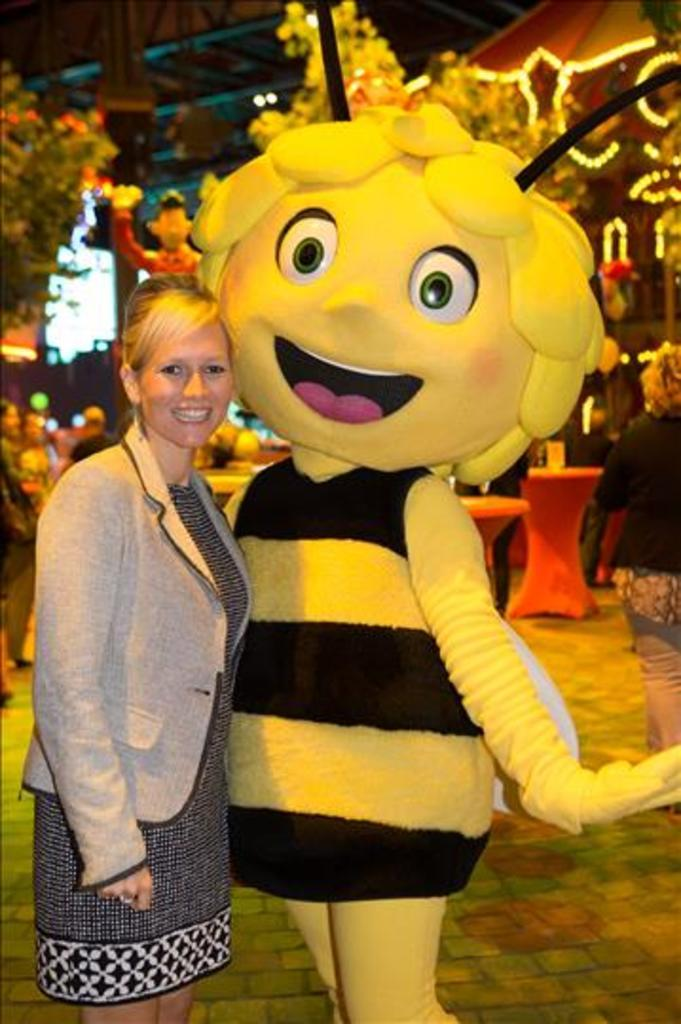What is the main subject of the image? There is a woman standing in the image. What is the woman doing in the image? The woman is standing at a mascot. Can you describe the background of the image? The background of the image is not clear, but there are trees, decorative lights, poles, and a few persons visible. What type of objects can be seen in the background? There are objects in the background, but their specific nature is not clear. What is the value of the paste used by the queen in the image? There is no queen or paste present in the image. What type of queen can be seen interacting with the mascot in the image? There is no queen present in the image; the main subject is a woman standing at a mascot. 